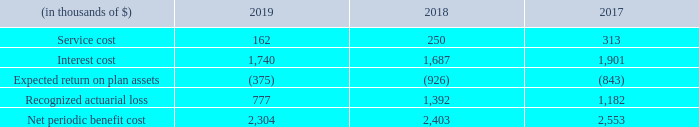22. PENSIONS
Defined contribution scheme
We operate a defined contribution scheme. The pension cost for the period represents contributions payable by us to the scheme. The charge to net income for the years ended December 31, 2019, 2018 and 2017 was $2.4 million, $1.9 million and $1.7 million, respectively.
Defined benefit schemes
We have two defined benefit pension plans both of which are closed to new entrants but still cover certain of our employees. Benefits are based on the employee's years of service and compensation. Net periodic pension plan costs are determined using the Projected Unit Credit Cost method. Our plans are funded by us in conformity with the funding requirements of the applicable government regulations. Plan assets consist of both fixed income and equity funds managed by professional fund managers. We have two defined benefit pension plans both of which are closed to new entrants but still cover certain of our employees. Benefits are based on the employee's years of service and compensation. Net periodic pension plan costs are determined using the Projected Unit Credit Cost method. Our plans are funded by us in conformity with the funding requirements of the applicable government regulations. Plan assets consist of both fixed income and equity funds managed by professional fund managers.
We use December 31 as a measurement date for our pension plans.
The components of net periodic benefit costs are as follows:
The components of net periodic benefit costs are recognized in the income statement within administrative expenses and vessel operating expenses.
The estimated net loss for the defined benefit pension plans that will be amortized from accumulated other comprehensive income into net periodic pension benefit cost during the year ended December 31, 2019 is $0.8 million (2018: $1.4 million).
What are the components of net periodic benefit costs? Service cost, interest cost, expected return on plan assets, recognized actuarial loss. How are net periodic pension plan costs determined? Using the projected unit credit cost method. What does plan assets comprise of? Fixed income and equity funds managed by professional fund managers. Which year was the interest cost the lowest? 1,687 < 1,740 <1,901
Answer: 2018. What was the change in service cost from 2017 to 2018?
Answer scale should be: thousand. 250 - 313 
Answer: -63. What was the percentage change in net periodic benefit cost from 2018 to 2019?
Answer scale should be: percent. (2,304 - 2,403)/2,403 
Answer: -4.12. 